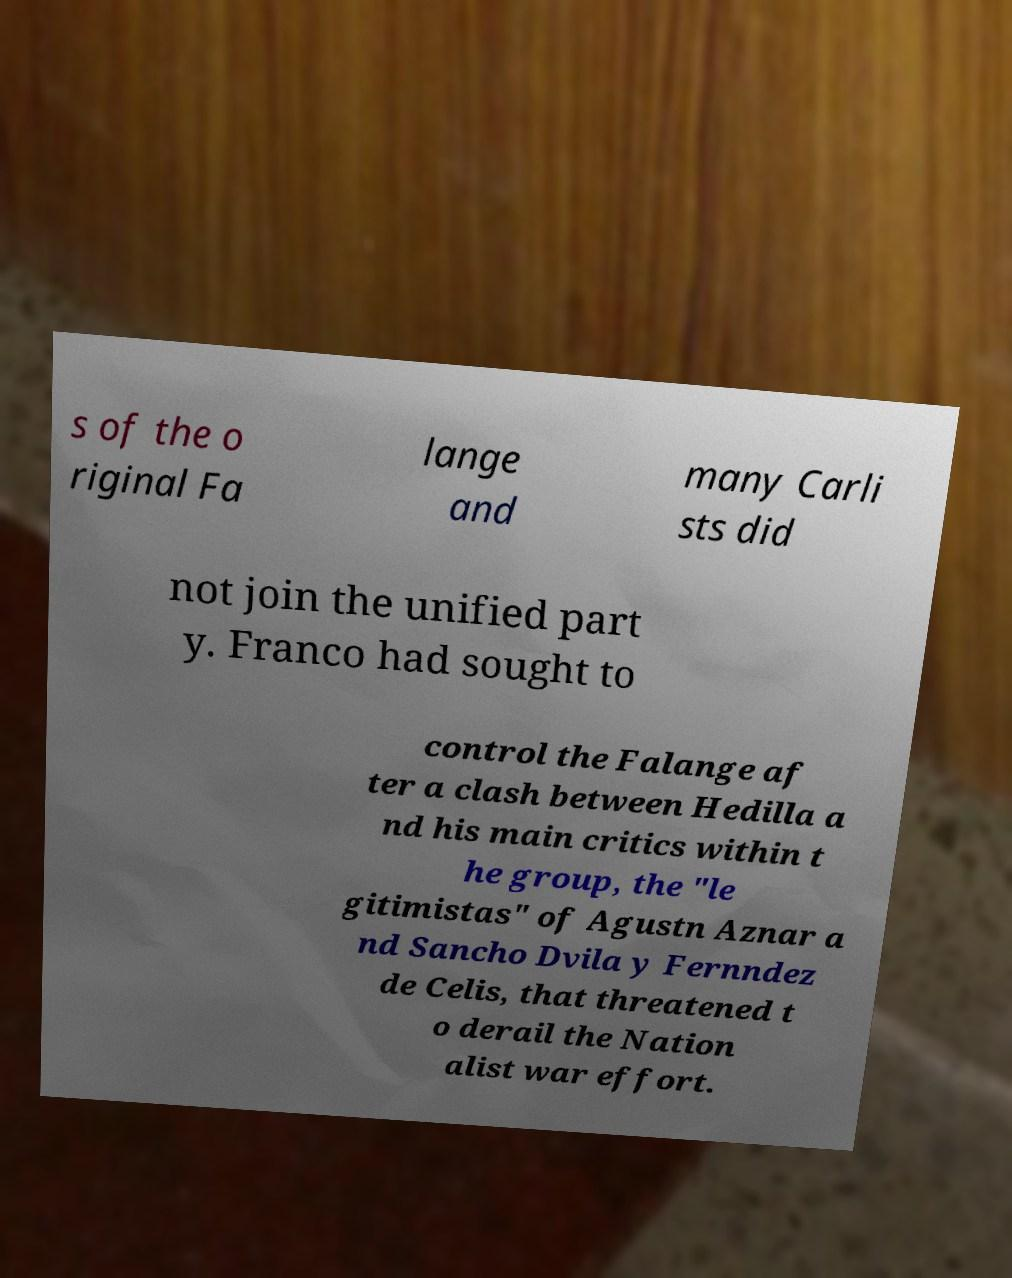What messages or text are displayed in this image? I need them in a readable, typed format. s of the o riginal Fa lange and many Carli sts did not join the unified part y. Franco had sought to control the Falange af ter a clash between Hedilla a nd his main critics within t he group, the "le gitimistas" of Agustn Aznar a nd Sancho Dvila y Fernndez de Celis, that threatened t o derail the Nation alist war effort. 